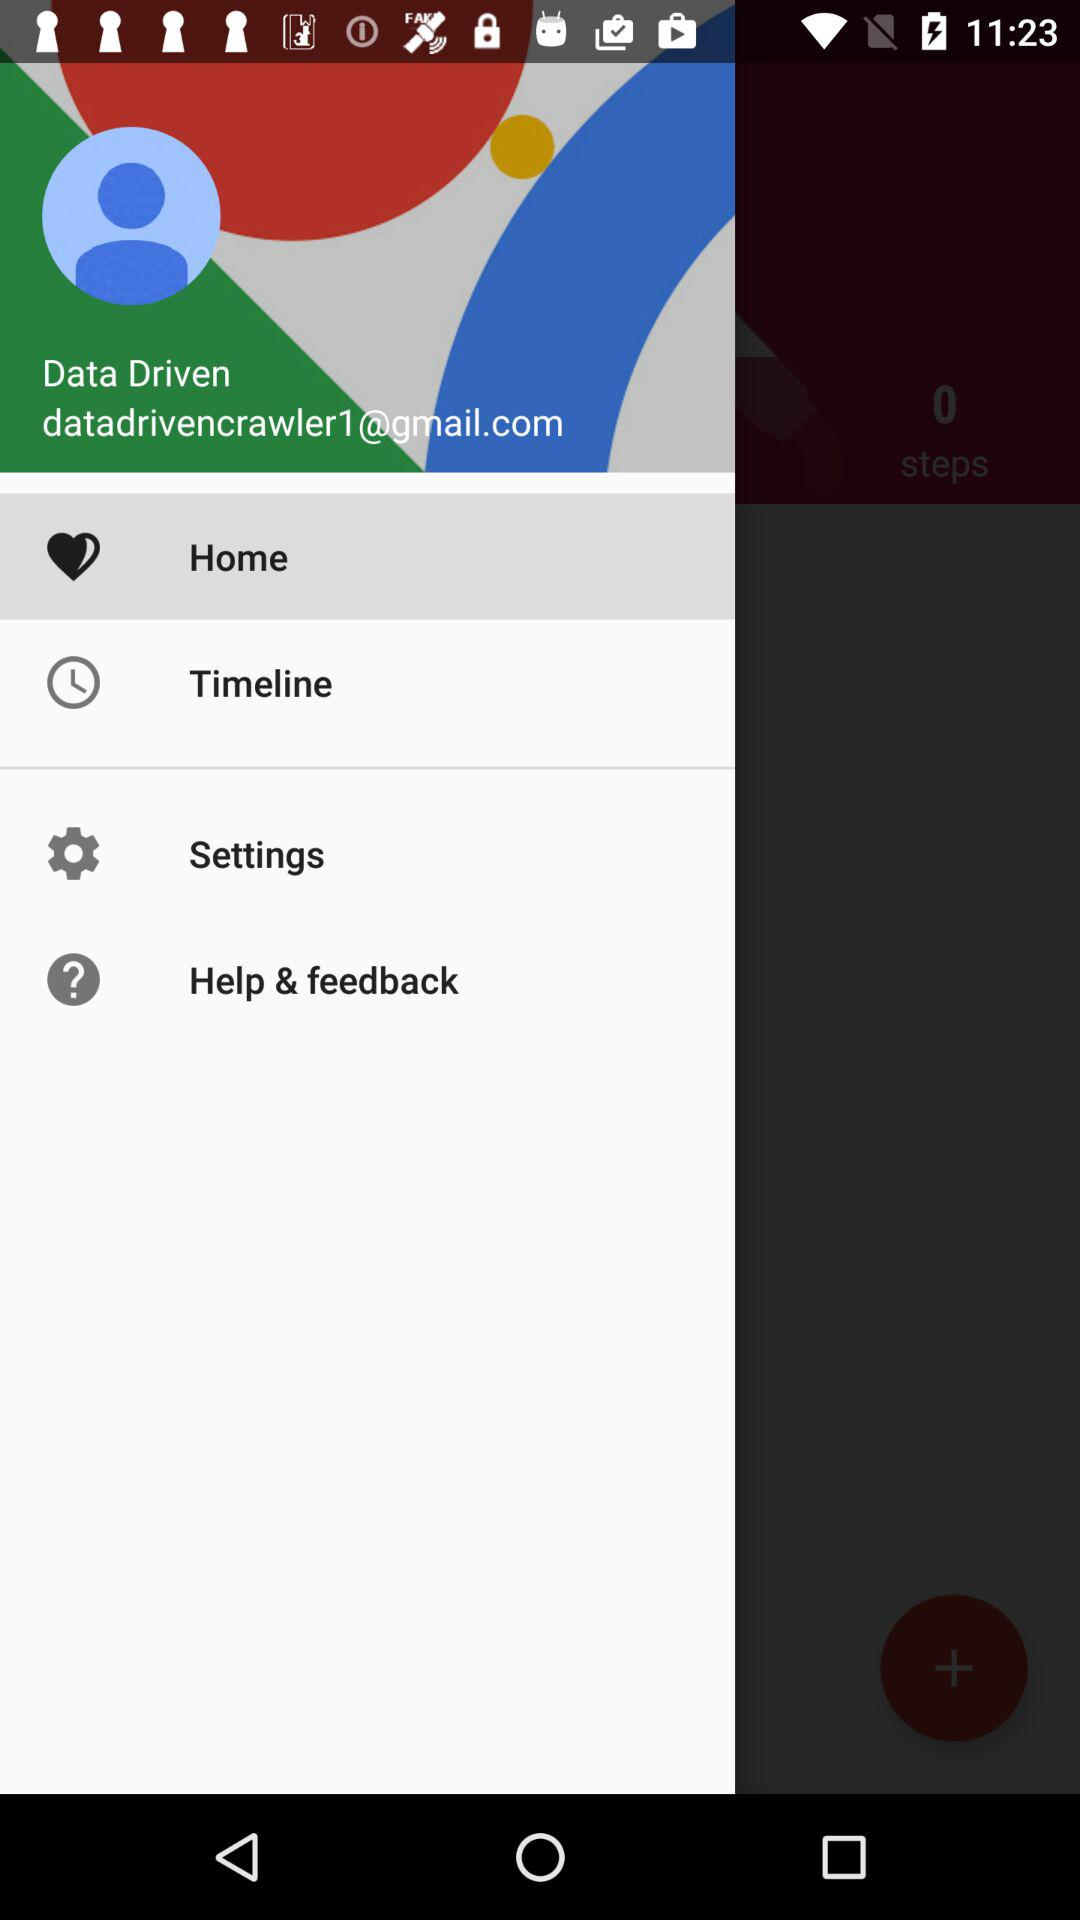Which option is highlighted? The highlighted option is "Home". 